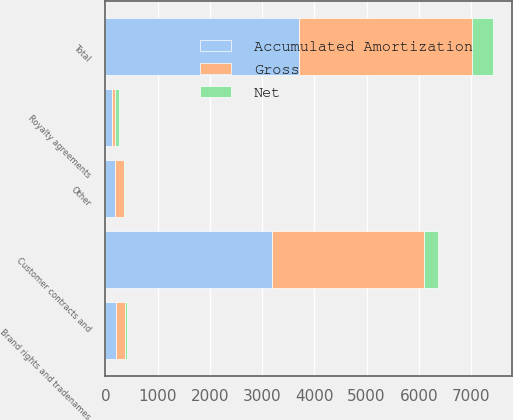<chart> <loc_0><loc_0><loc_500><loc_500><stacked_bar_chart><ecel><fcel>Customer contracts and<fcel>Brand rights and tradenames<fcel>Royalty agreements<fcel>Other<fcel>Total<nl><fcel>Accumulated Amortization<fcel>3184<fcel>208<fcel>129<fcel>190<fcel>3711<nl><fcel>Net<fcel>261<fcel>33<fcel>70<fcel>33<fcel>397<nl><fcel>Gross<fcel>2923<fcel>175<fcel>59<fcel>157<fcel>3314<nl></chart> 